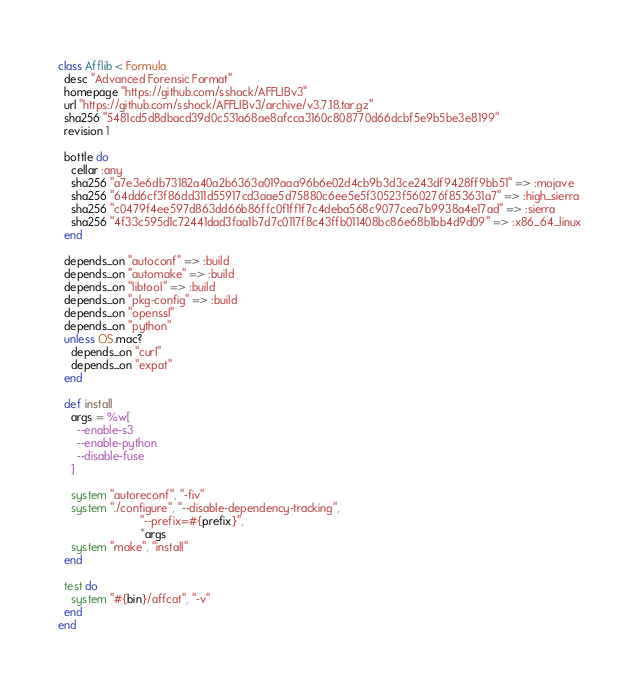Convert code to text. <code><loc_0><loc_0><loc_500><loc_500><_Ruby_>class Afflib < Formula
  desc "Advanced Forensic Format"
  homepage "https://github.com/sshock/AFFLIBv3"
  url "https://github.com/sshock/AFFLIBv3/archive/v3.7.18.tar.gz"
  sha256 "5481cd5d8dbacd39d0c531a68ae8afcca3160c808770d66dcbf5e9b5be3e8199"
  revision 1

  bottle do
    cellar :any
    sha256 "a7e3e6db73182a40a2b6363a019aaa96b6e02d4cb9b3d3ce243df9428ff9bb51" => :mojave
    sha256 "64dd6cf3f86dd311d55917cd3aae5d75880c6ee5e5f30523f560276f853631a7" => :high_sierra
    sha256 "c0479f4ee597d863dd66b86ffc0f1ff1f7c4deba568c9077cea7b9938a4e17ad" => :sierra
    sha256 "4f33c595d1c72441dad3faa1b7d7c0117f8c43ffb011408bc86e68b1bb4d9d09" => :x86_64_linux
  end

  depends_on "autoconf" => :build
  depends_on "automake" => :build
  depends_on "libtool" => :build
  depends_on "pkg-config" => :build
  depends_on "openssl"
  depends_on "python"
  unless OS.mac?
    depends_on "curl"
    depends_on "expat"
  end

  def install
    args = %w[
      --enable-s3
      --enable-python
      --disable-fuse
    ]

    system "autoreconf", "-fiv"
    system "./configure", "--disable-dependency-tracking",
                          "--prefix=#{prefix}",
                          *args
    system "make", "install"
  end

  test do
    system "#{bin}/affcat", "-v"
  end
end
</code> 